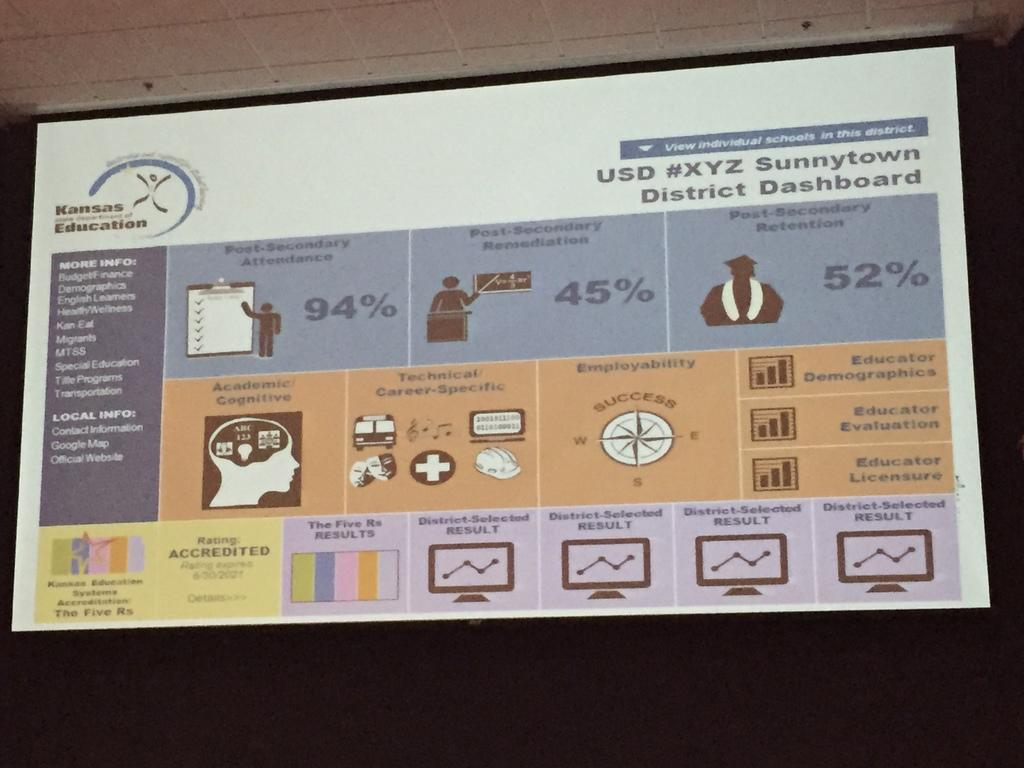<image>
Describe the image concisely. Statistics on a board displayed by the Sunnytown District 